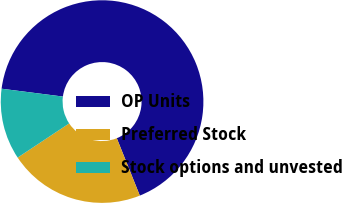<chart> <loc_0><loc_0><loc_500><loc_500><pie_chart><fcel>OP Units<fcel>Preferred Stock<fcel>Stock options and unvested<nl><fcel>66.9%<fcel>21.75%<fcel>11.35%<nl></chart> 